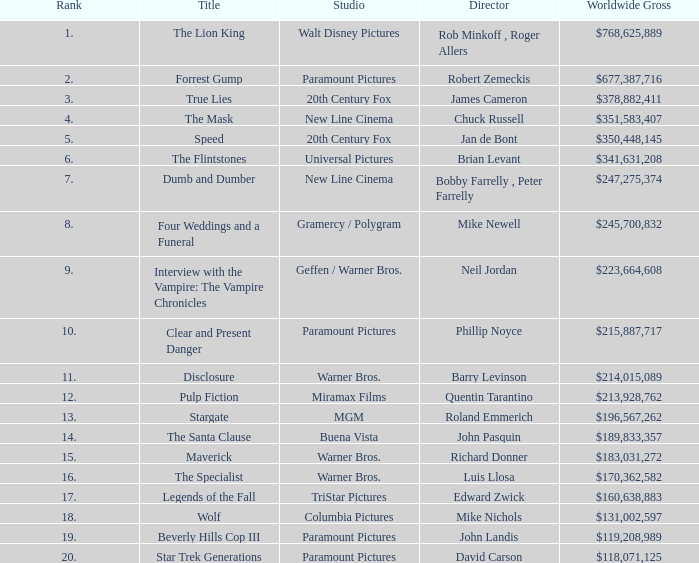What is the Rank of the Film with a Worldwide Gross of $183,031,272? 15.0. 